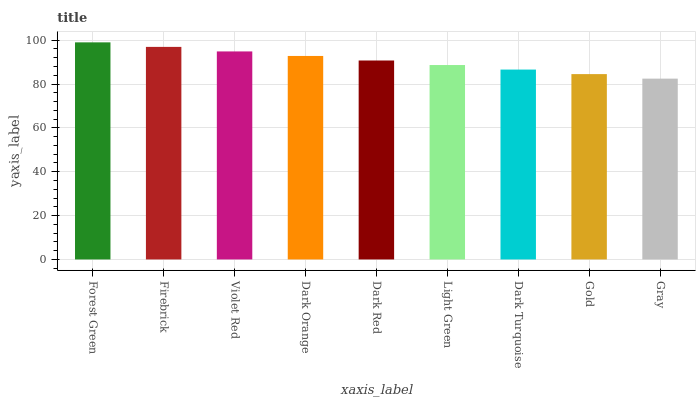Is Gray the minimum?
Answer yes or no. Yes. Is Forest Green the maximum?
Answer yes or no. Yes. Is Firebrick the minimum?
Answer yes or no. No. Is Firebrick the maximum?
Answer yes or no. No. Is Forest Green greater than Firebrick?
Answer yes or no. Yes. Is Firebrick less than Forest Green?
Answer yes or no. Yes. Is Firebrick greater than Forest Green?
Answer yes or no. No. Is Forest Green less than Firebrick?
Answer yes or no. No. Is Dark Red the high median?
Answer yes or no. Yes. Is Dark Red the low median?
Answer yes or no. Yes. Is Forest Green the high median?
Answer yes or no. No. Is Dark Turquoise the low median?
Answer yes or no. No. 